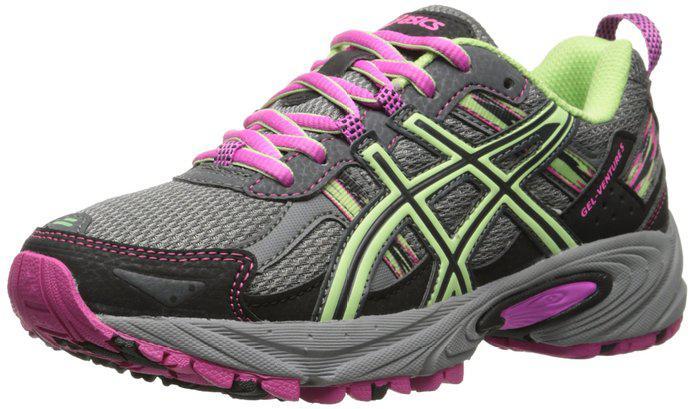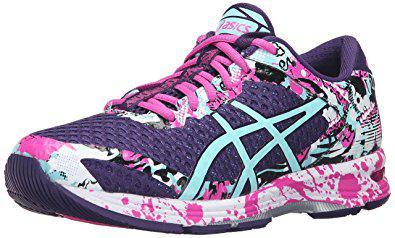The first image is the image on the left, the second image is the image on the right. Examine the images to the left and right. Is the description "Left and right images each contain a single sneaker, and the pair of images are arranged heel to heel." accurate? Answer yes or no. No. The first image is the image on the left, the second image is the image on the right. Evaluate the accuracy of this statement regarding the images: "Both shoes have pink shoelaces.". Is it true? Answer yes or no. Yes. 